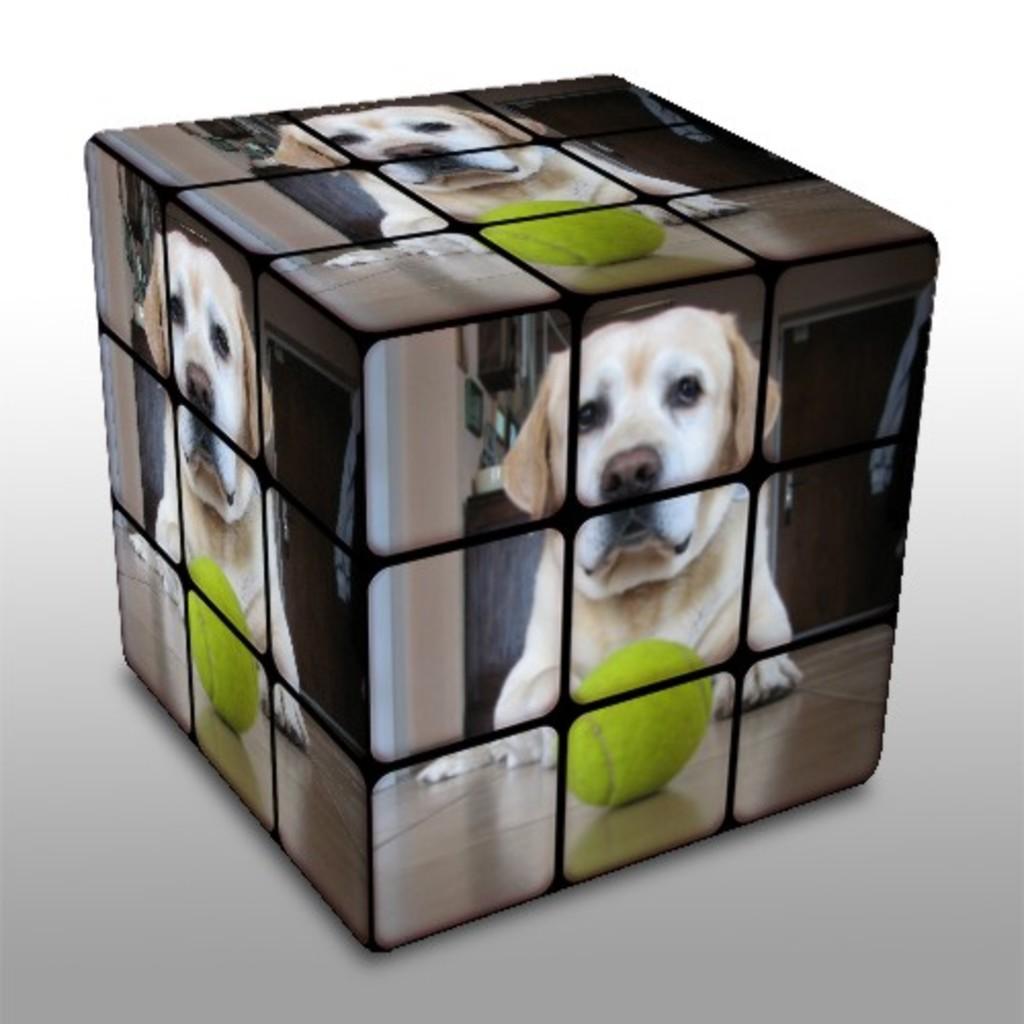Describe this image in one or two sentences. This is an edited image in which there is a ball and there is a dog. In the background there is a door and there is a table, on the table there are objects and on the wall there are frames. 